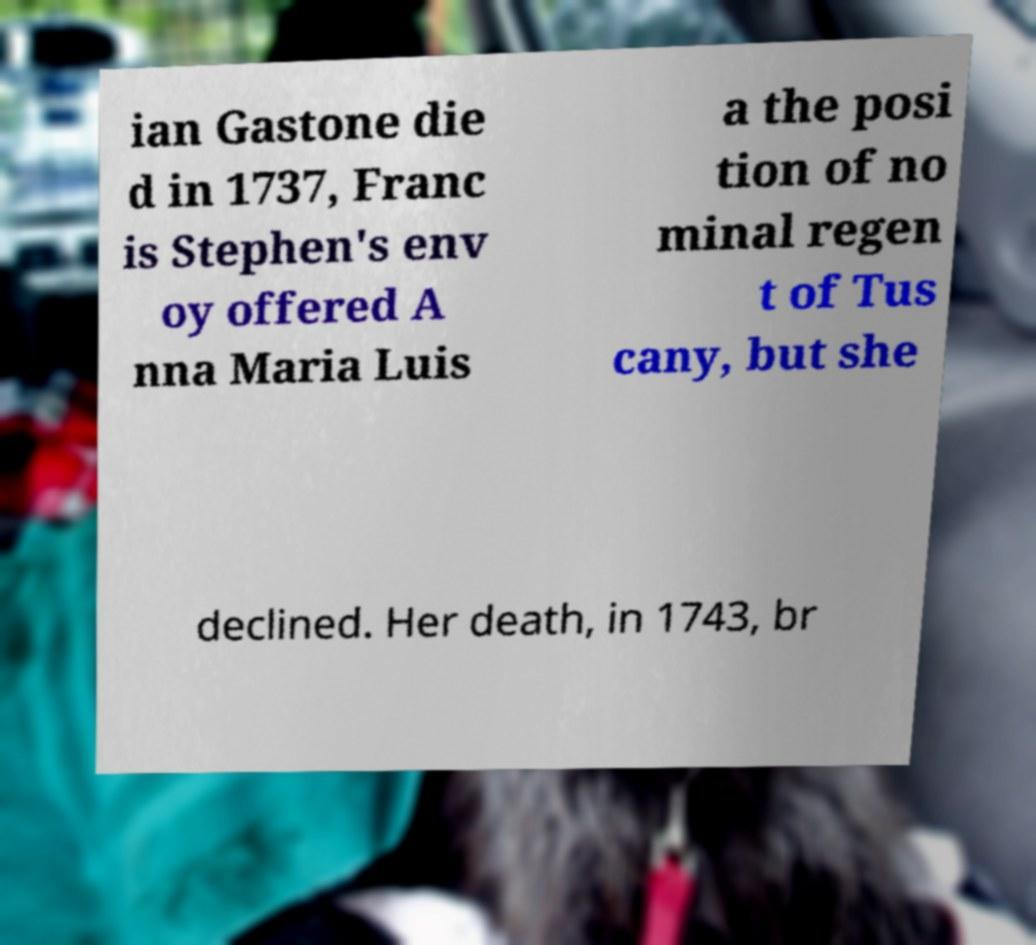Could you extract and type out the text from this image? ian Gastone die d in 1737, Franc is Stephen's env oy offered A nna Maria Luis a the posi tion of no minal regen t of Tus cany, but she declined. Her death, in 1743, br 